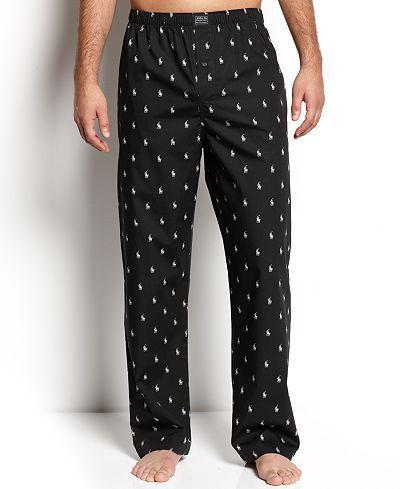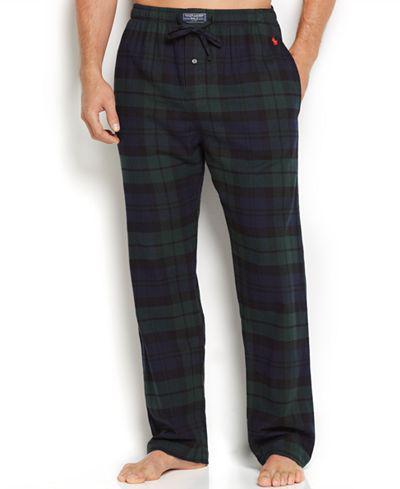The first image is the image on the left, the second image is the image on the right. Examine the images to the left and right. Is the description "One pair of pajama pants is a solid color." accurate? Answer yes or no. No. 